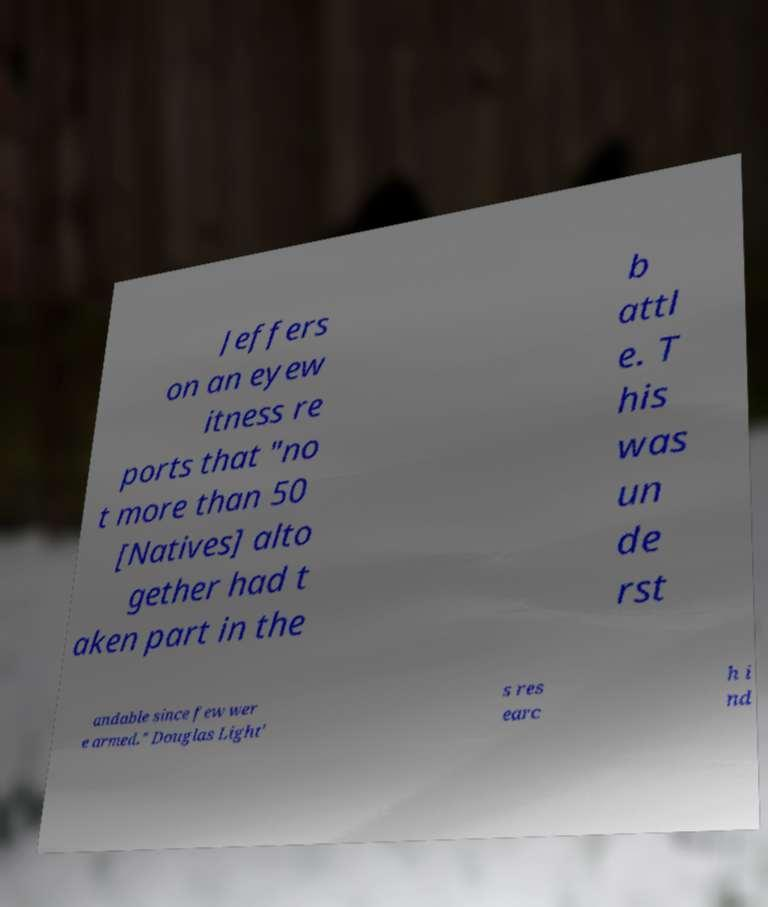Please read and relay the text visible in this image. What does it say? Jeffers on an eyew itness re ports that "no t more than 50 [Natives] alto gether had t aken part in the b attl e. T his was un de rst andable since few wer e armed." Douglas Light' s res earc h i nd 